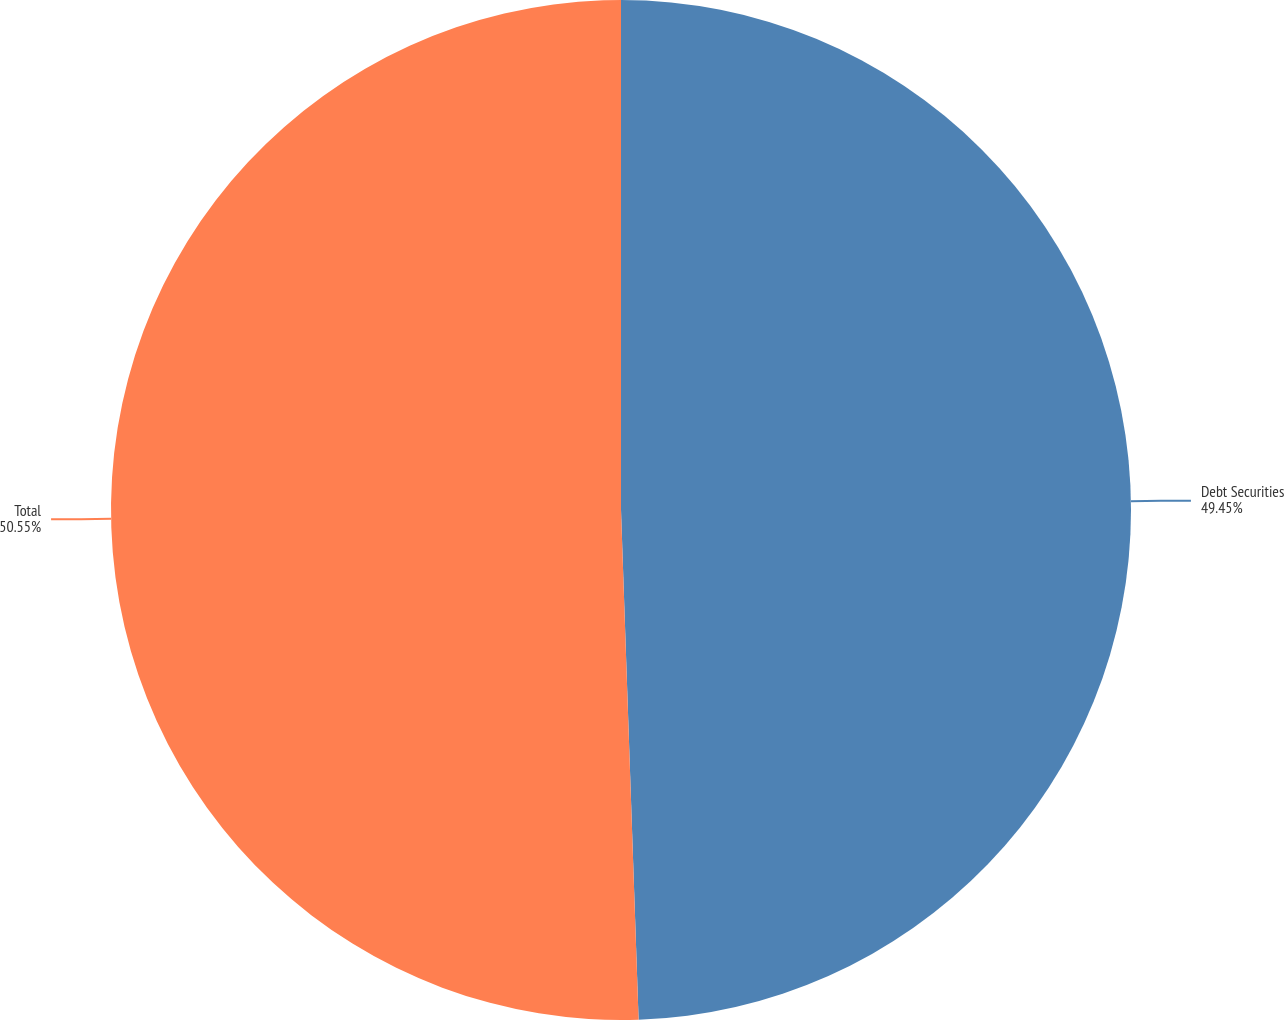Convert chart to OTSL. <chart><loc_0><loc_0><loc_500><loc_500><pie_chart><fcel>Debt Securities<fcel>Total<nl><fcel>49.45%<fcel>50.55%<nl></chart> 